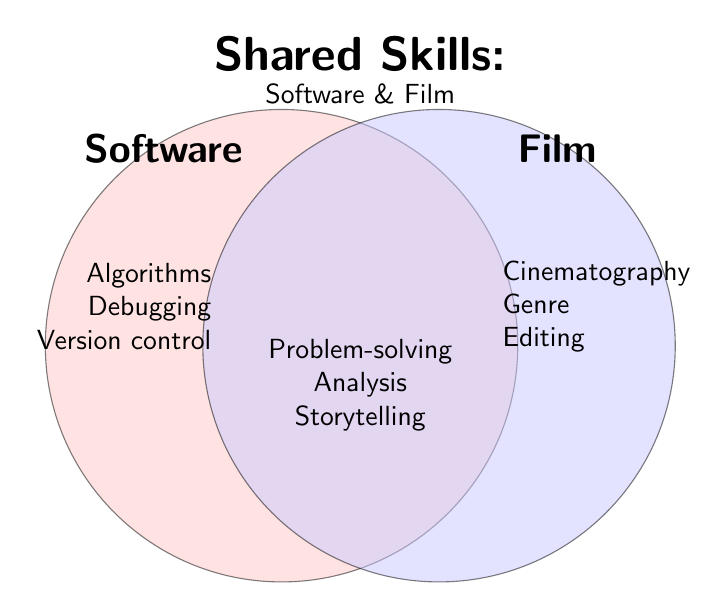What is the title of the Venn diagram? The title is located at the top of the figure and helps to understand the main topic of the chart.
Answer: Shared Skills: Software & Film Which area in the Venn diagram represents shared skills between software development and film analysis? The shared area is visually indicated by the overlap of the two circles, representing where the skills intersect.
Answer: Both How many skills are listed exclusively under software development? The figure lists three skills under software development on the left side: Algorithms, Debugging, and Version control.
Answer: Three How many skills are shared between software development and film analysis? There are four skills listed in the overlapping section of the Venn diagram: Problem-solving, Critical thinking, Attention to detail, and Analysis skills.
Answer: Four Which specific skill found in software development is likely needed for managing code changes? By examining the list under software development, the skill related to managing code changes is "Version control."
Answer: Version control Which side of the diagram contains skills related to film analysis? The right side of the diagram contains skills related to film analysis, visible by the blue circle representing "Film."
Answer: Right side Which shared skill in the Venn diagram could be beneficial both for debugging in software and for editing in films? The skill found in the overlapping section that can be beneficial in both debugging and editing is "Attention to detail."
Answer: Attention to detail Are the skills “User experience” and “Storytelling” listed under software development, film analysis, or shared? Both “User experience” and “Storytelling” are listed under the shared skills section found in the overlap of the Venn diagram.
Answer: Shared Which unique skill from film analysis can be compared to testing in software development? In the film analysis section, "Editing techniques" can be compared to "Testing" in software development as both involve refining and examining work for quality.
Answer: Editing techniques 